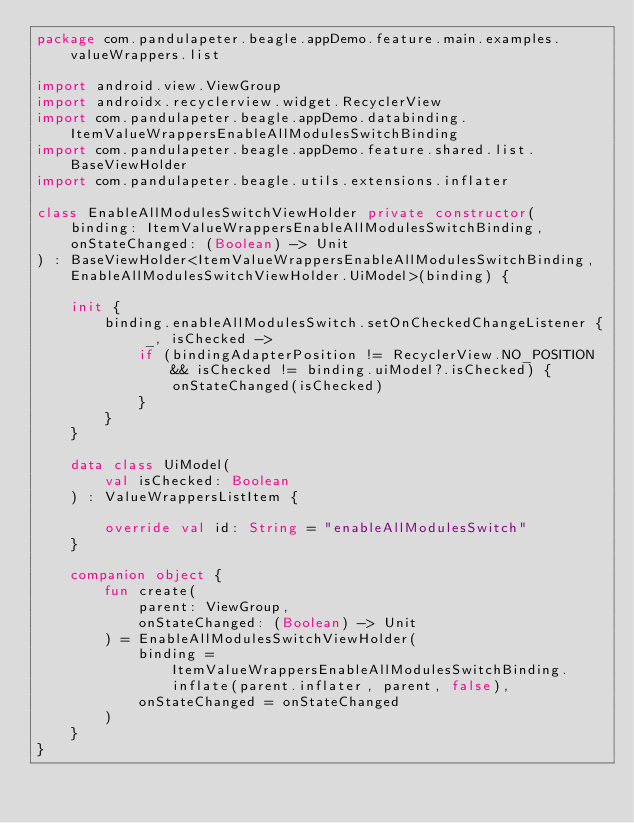Convert code to text. <code><loc_0><loc_0><loc_500><loc_500><_Kotlin_>package com.pandulapeter.beagle.appDemo.feature.main.examples.valueWrappers.list

import android.view.ViewGroup
import androidx.recyclerview.widget.RecyclerView
import com.pandulapeter.beagle.appDemo.databinding.ItemValueWrappersEnableAllModulesSwitchBinding
import com.pandulapeter.beagle.appDemo.feature.shared.list.BaseViewHolder
import com.pandulapeter.beagle.utils.extensions.inflater

class EnableAllModulesSwitchViewHolder private constructor(
    binding: ItemValueWrappersEnableAllModulesSwitchBinding,
    onStateChanged: (Boolean) -> Unit
) : BaseViewHolder<ItemValueWrappersEnableAllModulesSwitchBinding, EnableAllModulesSwitchViewHolder.UiModel>(binding) {

    init {
        binding.enableAllModulesSwitch.setOnCheckedChangeListener { _, isChecked ->
            if (bindingAdapterPosition != RecyclerView.NO_POSITION && isChecked != binding.uiModel?.isChecked) {
                onStateChanged(isChecked)
            }
        }
    }

    data class UiModel(
        val isChecked: Boolean
    ) : ValueWrappersListItem {

        override val id: String = "enableAllModulesSwitch"
    }

    companion object {
        fun create(
            parent: ViewGroup,
            onStateChanged: (Boolean) -> Unit
        ) = EnableAllModulesSwitchViewHolder(
            binding = ItemValueWrappersEnableAllModulesSwitchBinding.inflate(parent.inflater, parent, false),
            onStateChanged = onStateChanged
        )
    }
}</code> 